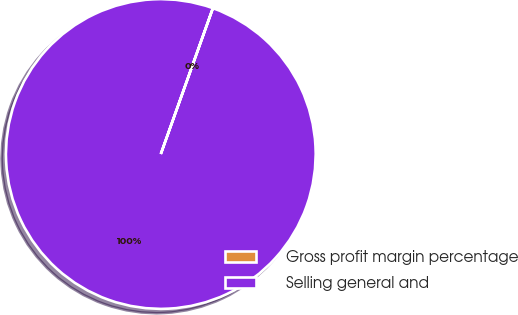Convert chart to OTSL. <chart><loc_0><loc_0><loc_500><loc_500><pie_chart><fcel>Gross profit margin percentage<fcel>Selling general and<nl><fcel>0.01%<fcel>99.99%<nl></chart> 